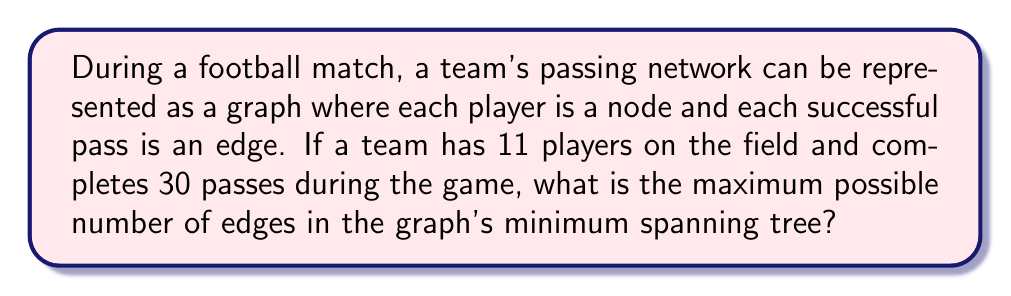Give your solution to this math problem. To solve this problem, we need to understand a few key concepts from graph theory:

1. A graph representing a team's passing network has players as nodes and passes as edges.
2. A spanning tree is a subgraph that connects all nodes (players) with the minimum number of edges (passes) without forming cycles.
3. The minimum spanning tree (MST) is a spanning tree with the lowest total weight. In this case, all edges have equal weight (1 pass), so any spanning tree is a minimum spanning tree.

Now, let's analyze the problem step by step:

1. Number of nodes (players): $n = 11$

2. The maximum number of edges in a minimum spanning tree is always $n - 1$, where $n$ is the number of nodes. This is because:
   a. A tree must connect all nodes without forming cycles.
   b. To connect $n$ nodes without cycles, we need exactly $n - 1$ edges.

3. Therefore, the maximum number of edges in the MST is:

   $$\text{Max edges in MST} = n - 1 = 11 - 1 = 10$$

It's important to note that the total number of passes (30) doesn't affect the answer, as we're only concerned with the minimum spanning tree. The MST will always have 10 edges, regardless of how many passes were actually made during the game.
Answer: 10 